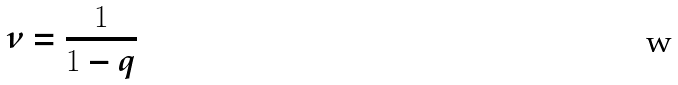Convert formula to latex. <formula><loc_0><loc_0><loc_500><loc_500>\nu = \frac { 1 } { 1 - q }</formula> 